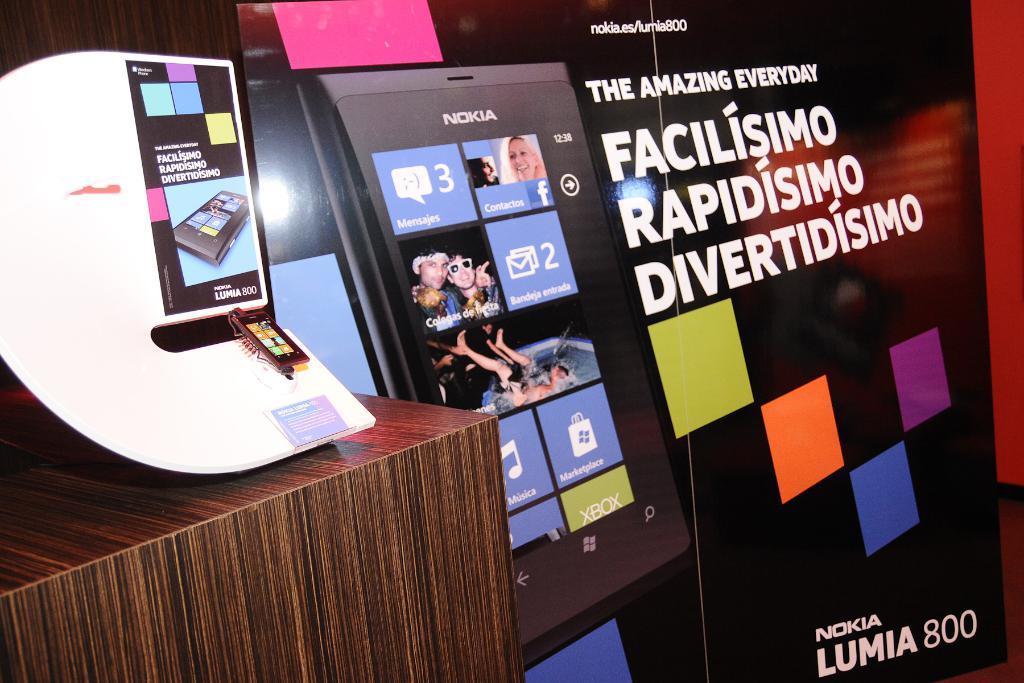Is the language presented spanish?
Your answer should be compact. Yes. What kind of phone is named on poster?
Provide a succinct answer. Nokia lumia 800. 